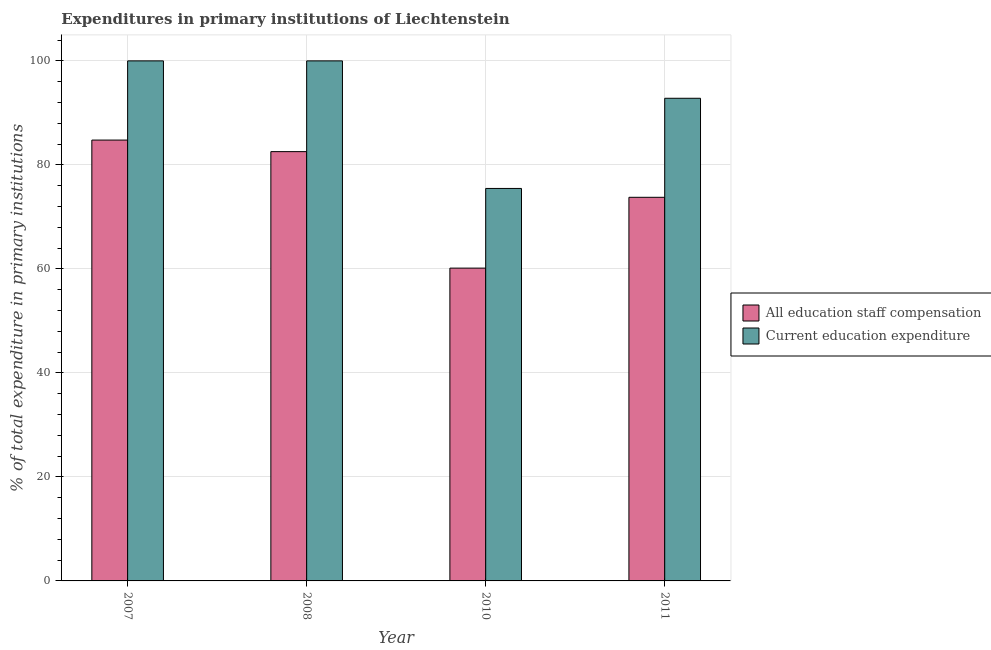How many different coloured bars are there?
Offer a terse response. 2. Are the number of bars per tick equal to the number of legend labels?
Your answer should be very brief. Yes. Are the number of bars on each tick of the X-axis equal?
Provide a short and direct response. Yes. How many bars are there on the 3rd tick from the left?
Provide a short and direct response. 2. What is the label of the 1st group of bars from the left?
Make the answer very short. 2007. What is the expenditure in education in 2010?
Offer a terse response. 75.47. Across all years, what is the maximum expenditure in education?
Your answer should be compact. 100. Across all years, what is the minimum expenditure in staff compensation?
Make the answer very short. 60.15. In which year was the expenditure in staff compensation maximum?
Offer a very short reply. 2007. What is the total expenditure in education in the graph?
Provide a short and direct response. 368.28. What is the difference between the expenditure in education in 2007 and that in 2011?
Provide a succinct answer. 7.19. What is the difference between the expenditure in staff compensation in 2011 and the expenditure in education in 2008?
Your answer should be compact. -8.78. What is the average expenditure in education per year?
Give a very brief answer. 92.07. What is the ratio of the expenditure in staff compensation in 2007 to that in 2010?
Provide a short and direct response. 1.41. Is the expenditure in staff compensation in 2008 less than that in 2011?
Your response must be concise. No. Is the difference between the expenditure in staff compensation in 2007 and 2008 greater than the difference between the expenditure in education in 2007 and 2008?
Give a very brief answer. No. What is the difference between the highest and the second highest expenditure in staff compensation?
Keep it short and to the point. 2.22. What is the difference between the highest and the lowest expenditure in education?
Offer a terse response. 24.53. What does the 1st bar from the left in 2007 represents?
Ensure brevity in your answer.  All education staff compensation. What does the 1st bar from the right in 2010 represents?
Provide a short and direct response. Current education expenditure. How many bars are there?
Your response must be concise. 8. Are the values on the major ticks of Y-axis written in scientific E-notation?
Make the answer very short. No. Does the graph contain grids?
Ensure brevity in your answer.  Yes. What is the title of the graph?
Your answer should be compact. Expenditures in primary institutions of Liechtenstein. What is the label or title of the Y-axis?
Make the answer very short. % of total expenditure in primary institutions. What is the % of total expenditure in primary institutions in All education staff compensation in 2007?
Make the answer very short. 84.77. What is the % of total expenditure in primary institutions in Current education expenditure in 2007?
Provide a succinct answer. 100. What is the % of total expenditure in primary institutions in All education staff compensation in 2008?
Your answer should be compact. 82.55. What is the % of total expenditure in primary institutions of All education staff compensation in 2010?
Make the answer very short. 60.15. What is the % of total expenditure in primary institutions of Current education expenditure in 2010?
Keep it short and to the point. 75.47. What is the % of total expenditure in primary institutions in All education staff compensation in 2011?
Give a very brief answer. 73.76. What is the % of total expenditure in primary institutions in Current education expenditure in 2011?
Ensure brevity in your answer.  92.81. Across all years, what is the maximum % of total expenditure in primary institutions in All education staff compensation?
Provide a short and direct response. 84.77. Across all years, what is the minimum % of total expenditure in primary institutions of All education staff compensation?
Provide a short and direct response. 60.15. Across all years, what is the minimum % of total expenditure in primary institutions of Current education expenditure?
Your answer should be very brief. 75.47. What is the total % of total expenditure in primary institutions in All education staff compensation in the graph?
Your response must be concise. 301.24. What is the total % of total expenditure in primary institutions of Current education expenditure in the graph?
Provide a short and direct response. 368.28. What is the difference between the % of total expenditure in primary institutions in All education staff compensation in 2007 and that in 2008?
Make the answer very short. 2.22. What is the difference between the % of total expenditure in primary institutions in All education staff compensation in 2007 and that in 2010?
Your answer should be compact. 24.62. What is the difference between the % of total expenditure in primary institutions in Current education expenditure in 2007 and that in 2010?
Provide a succinct answer. 24.53. What is the difference between the % of total expenditure in primary institutions of All education staff compensation in 2007 and that in 2011?
Your answer should be very brief. 11.01. What is the difference between the % of total expenditure in primary institutions of Current education expenditure in 2007 and that in 2011?
Your response must be concise. 7.19. What is the difference between the % of total expenditure in primary institutions in All education staff compensation in 2008 and that in 2010?
Offer a terse response. 22.4. What is the difference between the % of total expenditure in primary institutions in Current education expenditure in 2008 and that in 2010?
Keep it short and to the point. 24.53. What is the difference between the % of total expenditure in primary institutions in All education staff compensation in 2008 and that in 2011?
Provide a succinct answer. 8.79. What is the difference between the % of total expenditure in primary institutions of Current education expenditure in 2008 and that in 2011?
Keep it short and to the point. 7.19. What is the difference between the % of total expenditure in primary institutions in All education staff compensation in 2010 and that in 2011?
Offer a terse response. -13.61. What is the difference between the % of total expenditure in primary institutions in Current education expenditure in 2010 and that in 2011?
Ensure brevity in your answer.  -17.34. What is the difference between the % of total expenditure in primary institutions of All education staff compensation in 2007 and the % of total expenditure in primary institutions of Current education expenditure in 2008?
Provide a short and direct response. -15.23. What is the difference between the % of total expenditure in primary institutions in All education staff compensation in 2007 and the % of total expenditure in primary institutions in Current education expenditure in 2010?
Give a very brief answer. 9.3. What is the difference between the % of total expenditure in primary institutions in All education staff compensation in 2007 and the % of total expenditure in primary institutions in Current education expenditure in 2011?
Offer a very short reply. -8.04. What is the difference between the % of total expenditure in primary institutions in All education staff compensation in 2008 and the % of total expenditure in primary institutions in Current education expenditure in 2010?
Provide a succinct answer. 7.08. What is the difference between the % of total expenditure in primary institutions in All education staff compensation in 2008 and the % of total expenditure in primary institutions in Current education expenditure in 2011?
Keep it short and to the point. -10.26. What is the difference between the % of total expenditure in primary institutions in All education staff compensation in 2010 and the % of total expenditure in primary institutions in Current education expenditure in 2011?
Your answer should be compact. -32.66. What is the average % of total expenditure in primary institutions in All education staff compensation per year?
Your response must be concise. 75.31. What is the average % of total expenditure in primary institutions of Current education expenditure per year?
Ensure brevity in your answer.  92.07. In the year 2007, what is the difference between the % of total expenditure in primary institutions in All education staff compensation and % of total expenditure in primary institutions in Current education expenditure?
Make the answer very short. -15.23. In the year 2008, what is the difference between the % of total expenditure in primary institutions of All education staff compensation and % of total expenditure in primary institutions of Current education expenditure?
Make the answer very short. -17.45. In the year 2010, what is the difference between the % of total expenditure in primary institutions in All education staff compensation and % of total expenditure in primary institutions in Current education expenditure?
Your answer should be very brief. -15.32. In the year 2011, what is the difference between the % of total expenditure in primary institutions of All education staff compensation and % of total expenditure in primary institutions of Current education expenditure?
Make the answer very short. -19.05. What is the ratio of the % of total expenditure in primary institutions of All education staff compensation in 2007 to that in 2008?
Give a very brief answer. 1.03. What is the ratio of the % of total expenditure in primary institutions in All education staff compensation in 2007 to that in 2010?
Offer a very short reply. 1.41. What is the ratio of the % of total expenditure in primary institutions in Current education expenditure in 2007 to that in 2010?
Your response must be concise. 1.32. What is the ratio of the % of total expenditure in primary institutions of All education staff compensation in 2007 to that in 2011?
Give a very brief answer. 1.15. What is the ratio of the % of total expenditure in primary institutions in Current education expenditure in 2007 to that in 2011?
Give a very brief answer. 1.08. What is the ratio of the % of total expenditure in primary institutions in All education staff compensation in 2008 to that in 2010?
Your response must be concise. 1.37. What is the ratio of the % of total expenditure in primary institutions of Current education expenditure in 2008 to that in 2010?
Provide a short and direct response. 1.32. What is the ratio of the % of total expenditure in primary institutions in All education staff compensation in 2008 to that in 2011?
Make the answer very short. 1.12. What is the ratio of the % of total expenditure in primary institutions of Current education expenditure in 2008 to that in 2011?
Offer a terse response. 1.08. What is the ratio of the % of total expenditure in primary institutions of All education staff compensation in 2010 to that in 2011?
Provide a succinct answer. 0.82. What is the ratio of the % of total expenditure in primary institutions of Current education expenditure in 2010 to that in 2011?
Your answer should be very brief. 0.81. What is the difference between the highest and the second highest % of total expenditure in primary institutions of All education staff compensation?
Keep it short and to the point. 2.22. What is the difference between the highest and the second highest % of total expenditure in primary institutions of Current education expenditure?
Your response must be concise. 0. What is the difference between the highest and the lowest % of total expenditure in primary institutions of All education staff compensation?
Offer a terse response. 24.62. What is the difference between the highest and the lowest % of total expenditure in primary institutions of Current education expenditure?
Provide a succinct answer. 24.53. 